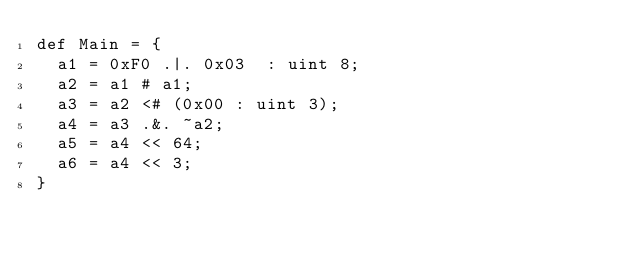<code> <loc_0><loc_0><loc_500><loc_500><_SQL_>def Main = {
  a1 = 0xF0 .|. 0x03  : uint 8;
  a2 = a1 # a1;
  a3 = a2 <# (0x00 : uint 3);
  a4 = a3 .&. ~a2;
  a5 = a4 << 64;
  a6 = a4 << 3;
}
</code> 